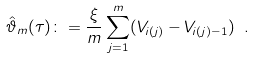<formula> <loc_0><loc_0><loc_500><loc_500>\hat { \vartheta } _ { m } ( \tau ) \colon = \frac { \xi } { m } \sum _ { j = 1 } ^ { m } ( V _ { i ( j ) } - V _ { i ( j ) - 1 } ) \ .</formula> 